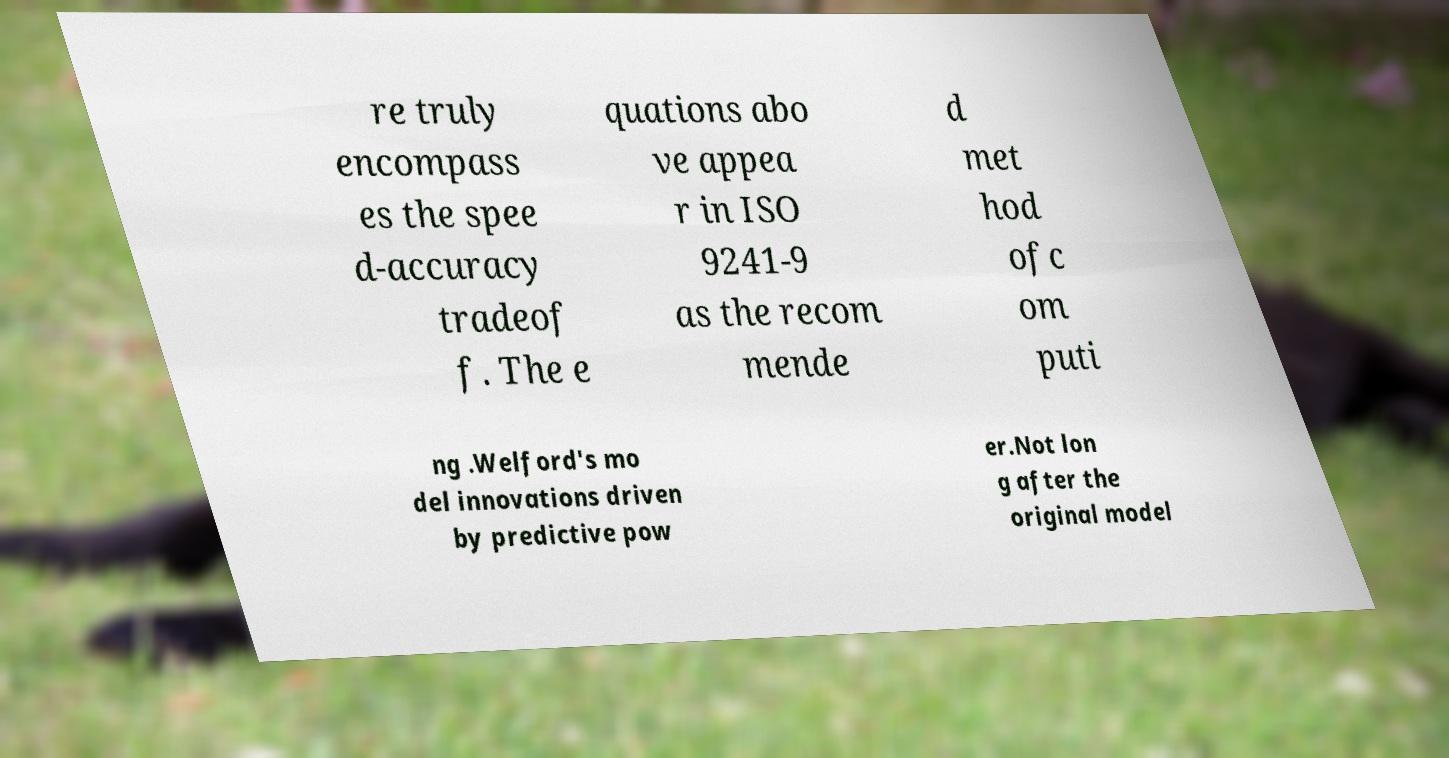Please identify and transcribe the text found in this image. re truly encompass es the spee d-accuracy tradeof f. The e quations abo ve appea r in ISO 9241-9 as the recom mende d met hod ofc om puti ng .Welford's mo del innovations driven by predictive pow er.Not lon g after the original model 